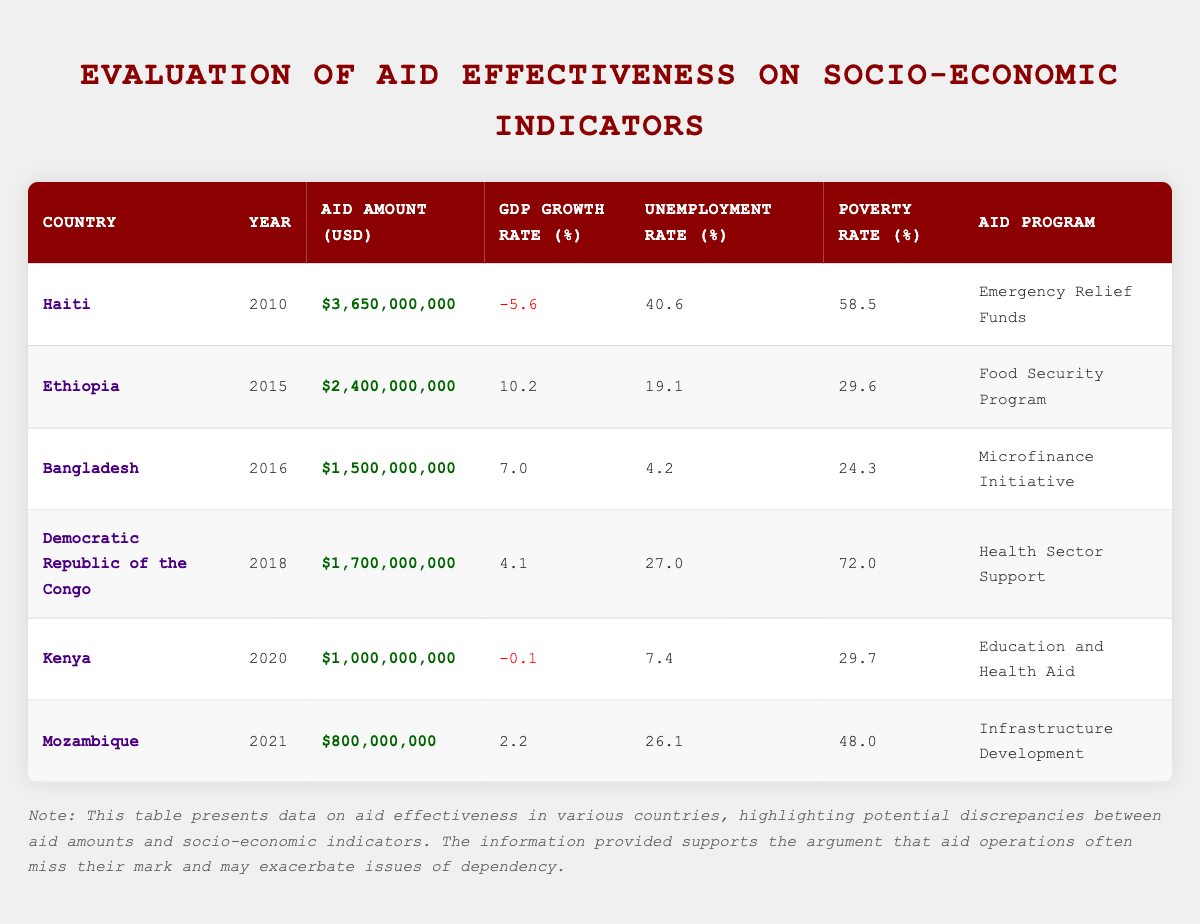What is the aid amount for Ethiopia in 2015? The table lists Ethiopia under the year 2015 with an aid amount recorded of 2,400,000,000 USD.
Answer: 2,400,000,000 USD What was the GDP growth rate in Haiti in 2010? The table shows that Haiti's GDP growth rate for the year 2010 is -5.6%.
Answer: -5.6% Which country had the highest poverty rate recorded in this data? By comparing the poverty rates listed in the table, Democratic Republic of the Congo has the highest rate at 72.0%.
Answer: Democratic Republic of the Congo What is the average unemployment rate across all countries in the table? The unemployment rates are 40.6, 19.1, 4.2, 27.0, 7.4, and 26.1. Summing these gives 124.4, and dividing by 6 results in an average unemployment rate of 20.73%.
Answer: 20.73% Did Kenya receive more or less aid than Mozambique? The aid amount for Kenya is 1,000,000,000 USD, while Mozambique received 800,000,000 USD. Since 1,000,000,000 is greater than 800,000,000, the answer is more.
Answer: More What is the difference in GDP growth rates between Ethiopia and the Democratic Republic of the Congo? Ethiopia's GDP growth rate is 10.2%, and the Democratic Republic of the Congo's is 4.1%. The difference is calculated by subtracting 4.1 from 10.2, resulting in a difference of 6.1%.
Answer: 6.1% Was there any country listed that experienced a negative GDP growth rate? The table indicates that both Haiti and Kenya had negative GDP growth rates of -5.6% and -0.1% respectively. Therefore, the answer is yes.
Answer: Yes Which aid program corresponds with the lowest unemployment rate? The table shows that Bangladesh has the lowest unemployment rate of 4.2%, which corresponds to the Microfinance Initiative.
Answer: Microfinance Initiative What is the total aid amount provided to all countries listed in the table? Summing the aid amounts: 3,650,000,000 + 2,400,000,000 + 1,500,000,000 + 1,700,000,000 + 1,000,000,000 + 800,000,000 equals 11,050,000,000 USD.
Answer: 11,050,000,000 USD 